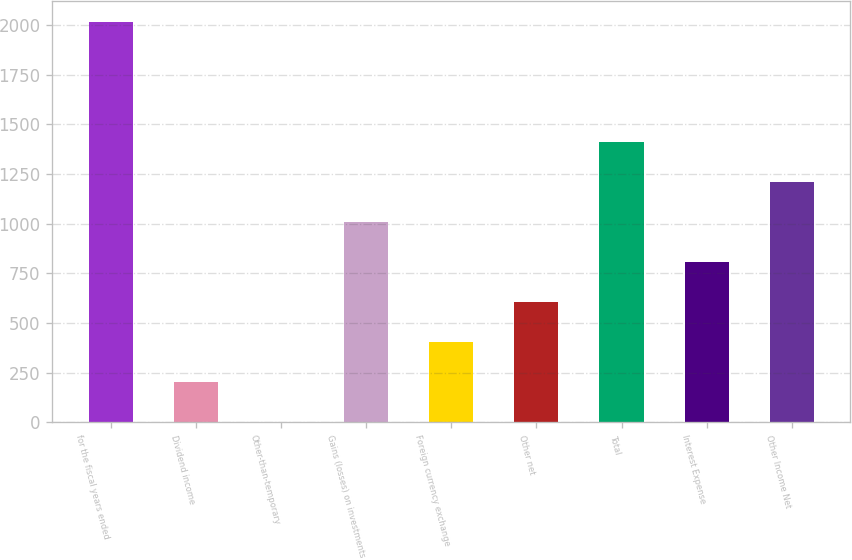Convert chart. <chart><loc_0><loc_0><loc_500><loc_500><bar_chart><fcel>for the fiscal years ended<fcel>Dividend income<fcel>Other-than-temporary<fcel>Gains (losses) on investments<fcel>Foreign currency exchange<fcel>Other net<fcel>Total<fcel>Interest Expense<fcel>Other Income Net<nl><fcel>2017<fcel>202.42<fcel>0.8<fcel>1008.9<fcel>404.04<fcel>605.66<fcel>1412.14<fcel>807.28<fcel>1210.52<nl></chart> 